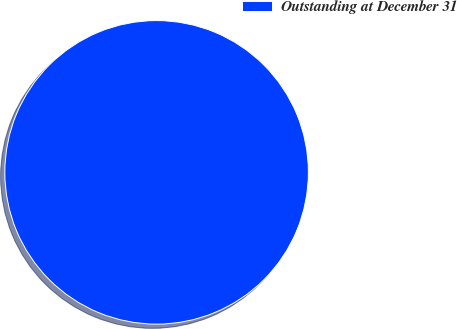<chart> <loc_0><loc_0><loc_500><loc_500><pie_chart><fcel>Outstanding at December 31<nl><fcel>100.0%<nl></chart> 